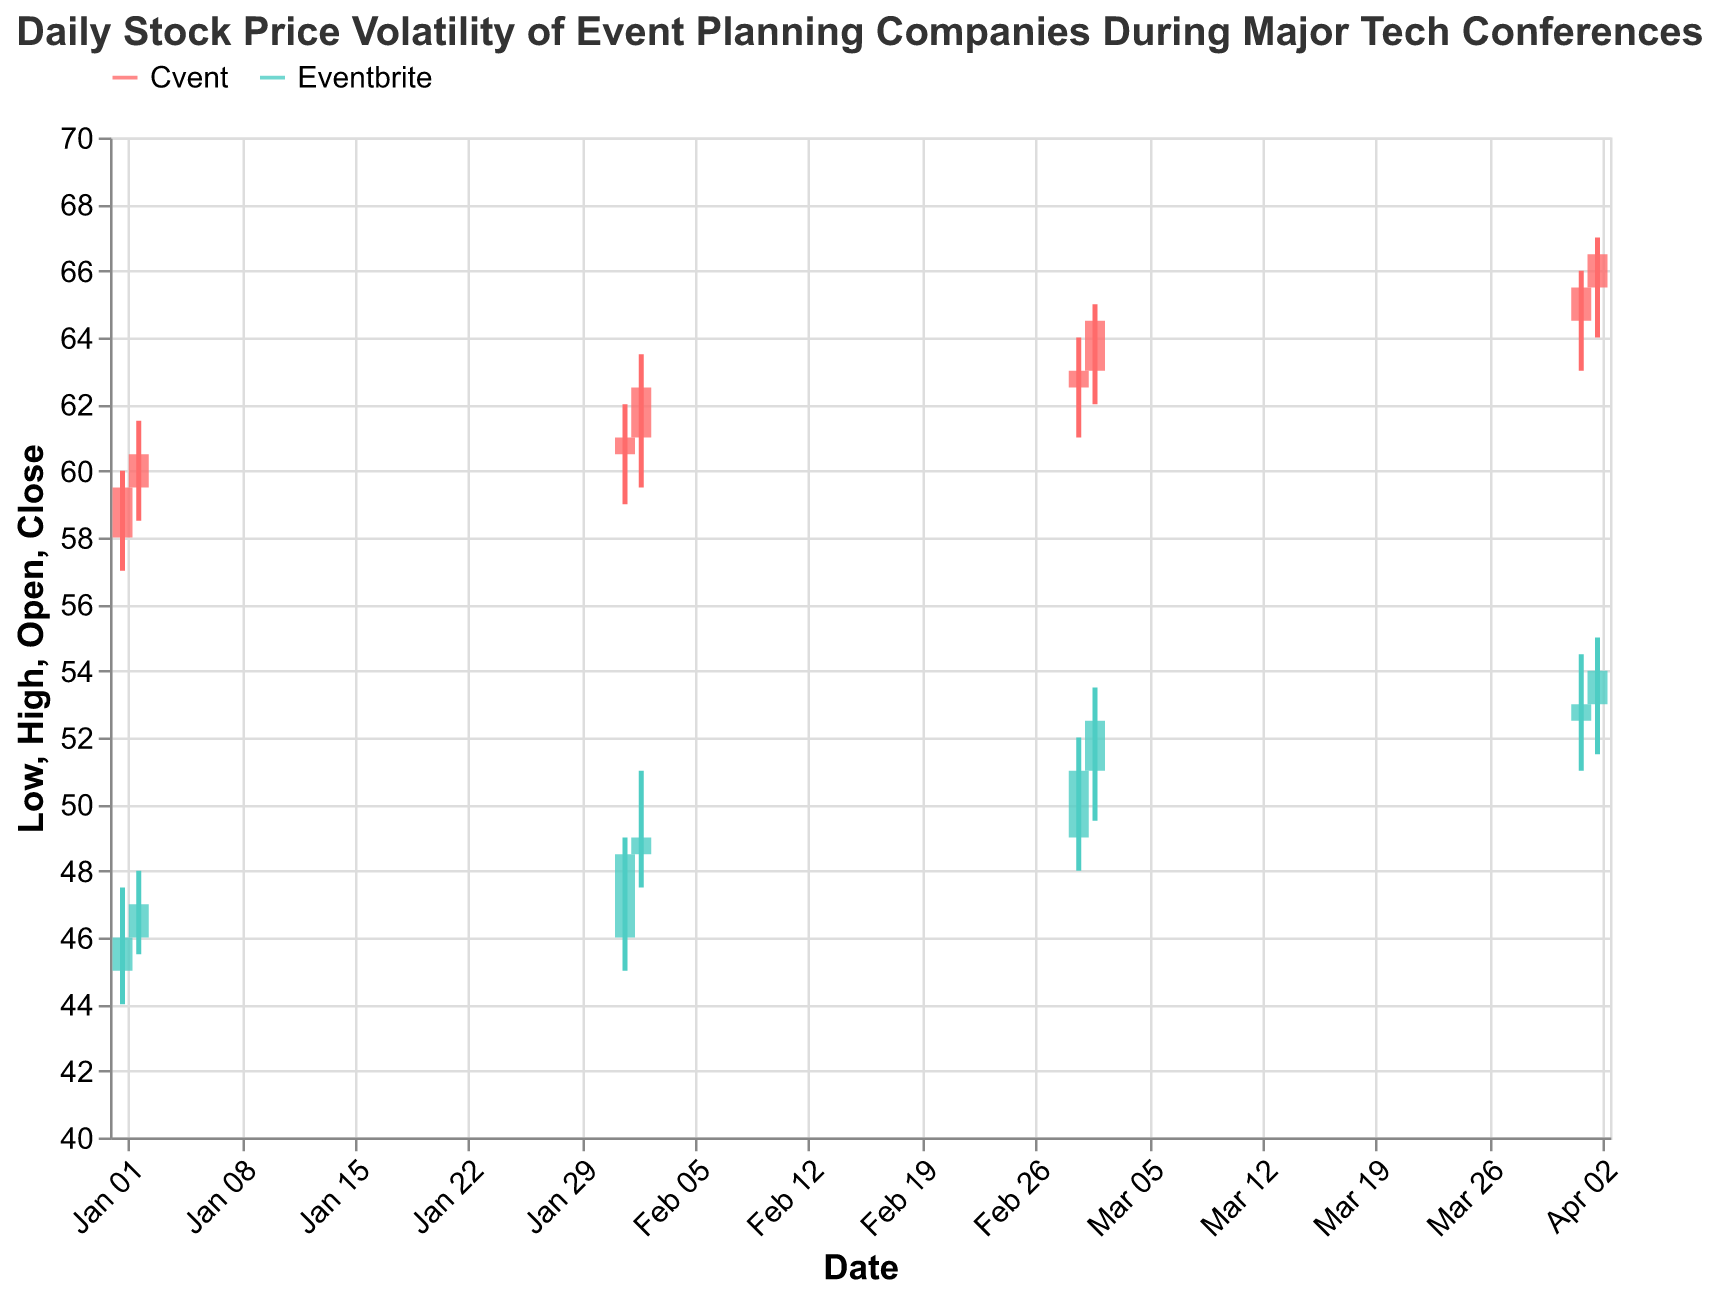What is the highest stock price for Cvent on January 1, 2023? The highest stock price for Cvent on January 1, 2023 is indicated by the upper end of the wick on the candlestick for that date. By checking the figure, we see the highest point of the candlestick wick for Cvent on January 1 is at 60.00.
Answer: 60.00 Which company has a higher closing stock price on February 2, 2023? To determine this, we compare the closing prices of both companies on February 2, 2023. Eventbrite's closing price is 49.00 and Cvent's closing price is 62.50. Cvent has a higher closing stock price.
Answer: Cvent What is the average opening stock price for Eventbrite in March 2023? Calculate the average of Eventbrite's opening stock prices on March 1 and March 2. Eventbrite's opening prices are 49.00 and 51.00. The average is (49.00 + 51.00) / 2 = 50.00.
Answer: 50.00 By how much did Eventbrite's stock price change from the opening to the closing on January 2, 2023? Subtract the opening stock price from the closing stock price for Eventbrite on January 2, 2023. The opening price is 46.00, and the closing price is 47.00. The change is 47.00 - 46.00 = 1.00.
Answer: 1.00 Which company's stock had a larger range (difference between the high and low prices) on February 1, 2023? Calculate the range for both companies' stock prices. Eventbrite has High 49.00 and Low 45.00, range 49.00 - 45.00 = 4.00. Cvent has High 62.00 and Low 59.00, range 62.00 - 59.00 = 3.00. Eventbrite had a larger range.
Answer: Eventbrite What was the closing price of Eventbrite on April 2, 2023? Check the closing price of Eventbrite on April 2, 2023 from the candlestick for that date. The figure shows a closing price of 54.00.
Answer: 54.00 Compare the stock price movement of Cvent between January 1, 2023, and April 1, 2023. Did the stock price generally increase or decrease? To compare the movement, examine the opening price on January 1, 2023 (58.00) and the closing price on April 1, 2023 (65.50). Since 58.00 to 65.50 indicates an increase, the stock price generally increased.
Answer: Increased What is the total number of data points displayed for each company? Count the number of data entries for each company. Both Eventbrite and Cvent have data for January 1 & 2, February 1 & 2, March 1 & 2, and April 1 & 2, which totals to 8 data points per company.
Answer: 8 Which date had the highest stock price volatility for Eventbrite, and what was the range of prices on that date? To find this, identify the date with the highest range between high and low prices for Eventbrite. On March 1, 2023, Eventbrite had a High of 52.00 and a Low of 48.00, giving a range of 4.00. This is the highest volatility.
Answer: March 1, 2023, range is 4.00 